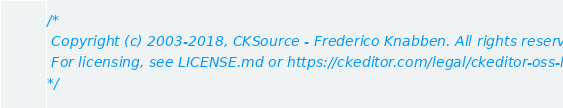Convert code to text. <code><loc_0><loc_0><loc_500><loc_500><_JavaScript_>/*
 Copyright (c) 2003-2018, CKSource - Frederico Knabben. All rights reserved.
 For licensing, see LICENSE.md or https://ckeditor.com/legal/ckeditor-oss-license
*/
</code> 